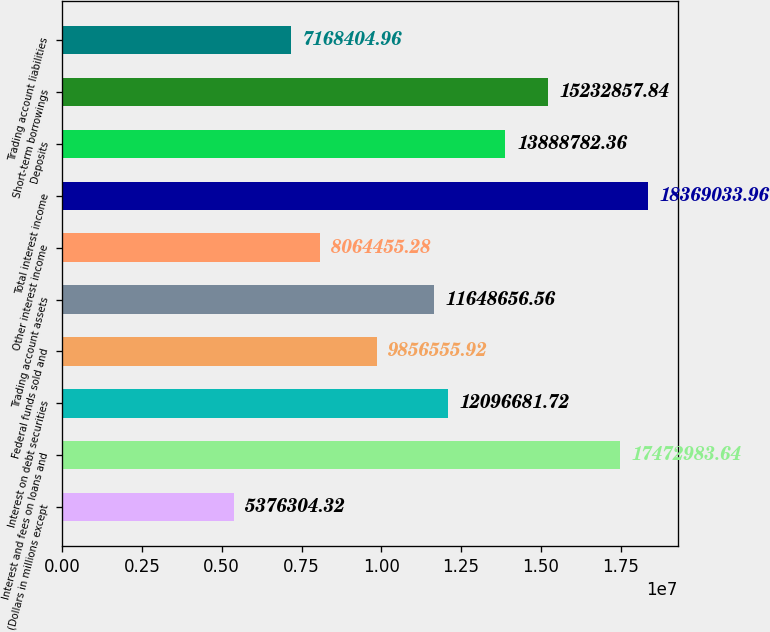Convert chart to OTSL. <chart><loc_0><loc_0><loc_500><loc_500><bar_chart><fcel>(Dollars in millions except<fcel>Interest and fees on loans and<fcel>Interest on debt securities<fcel>Federal funds sold and<fcel>Trading account assets<fcel>Other interest income<fcel>Total interest income<fcel>Deposits<fcel>Short-term borrowings<fcel>Trading account liabilities<nl><fcel>5.3763e+06<fcel>1.7473e+07<fcel>1.20967e+07<fcel>9.85656e+06<fcel>1.16487e+07<fcel>8.06446e+06<fcel>1.8369e+07<fcel>1.38888e+07<fcel>1.52329e+07<fcel>7.1684e+06<nl></chart> 